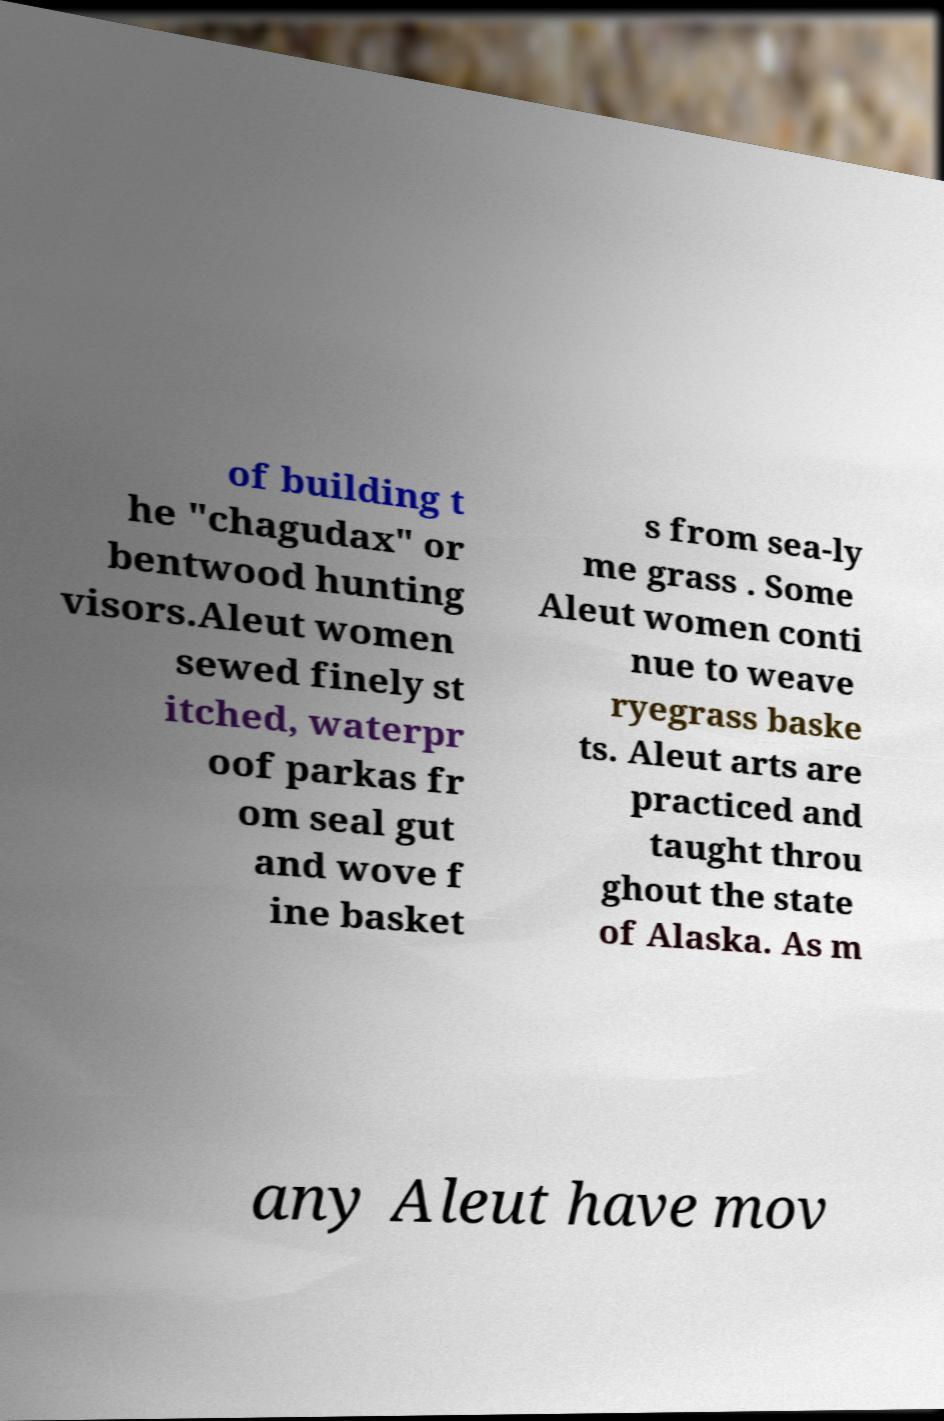Can you read and provide the text displayed in the image?This photo seems to have some interesting text. Can you extract and type it out for me? of building t he "chagudax" or bentwood hunting visors.Aleut women sewed finely st itched, waterpr oof parkas fr om seal gut and wove f ine basket s from sea-ly me grass . Some Aleut women conti nue to weave ryegrass baske ts. Aleut arts are practiced and taught throu ghout the state of Alaska. As m any Aleut have mov 